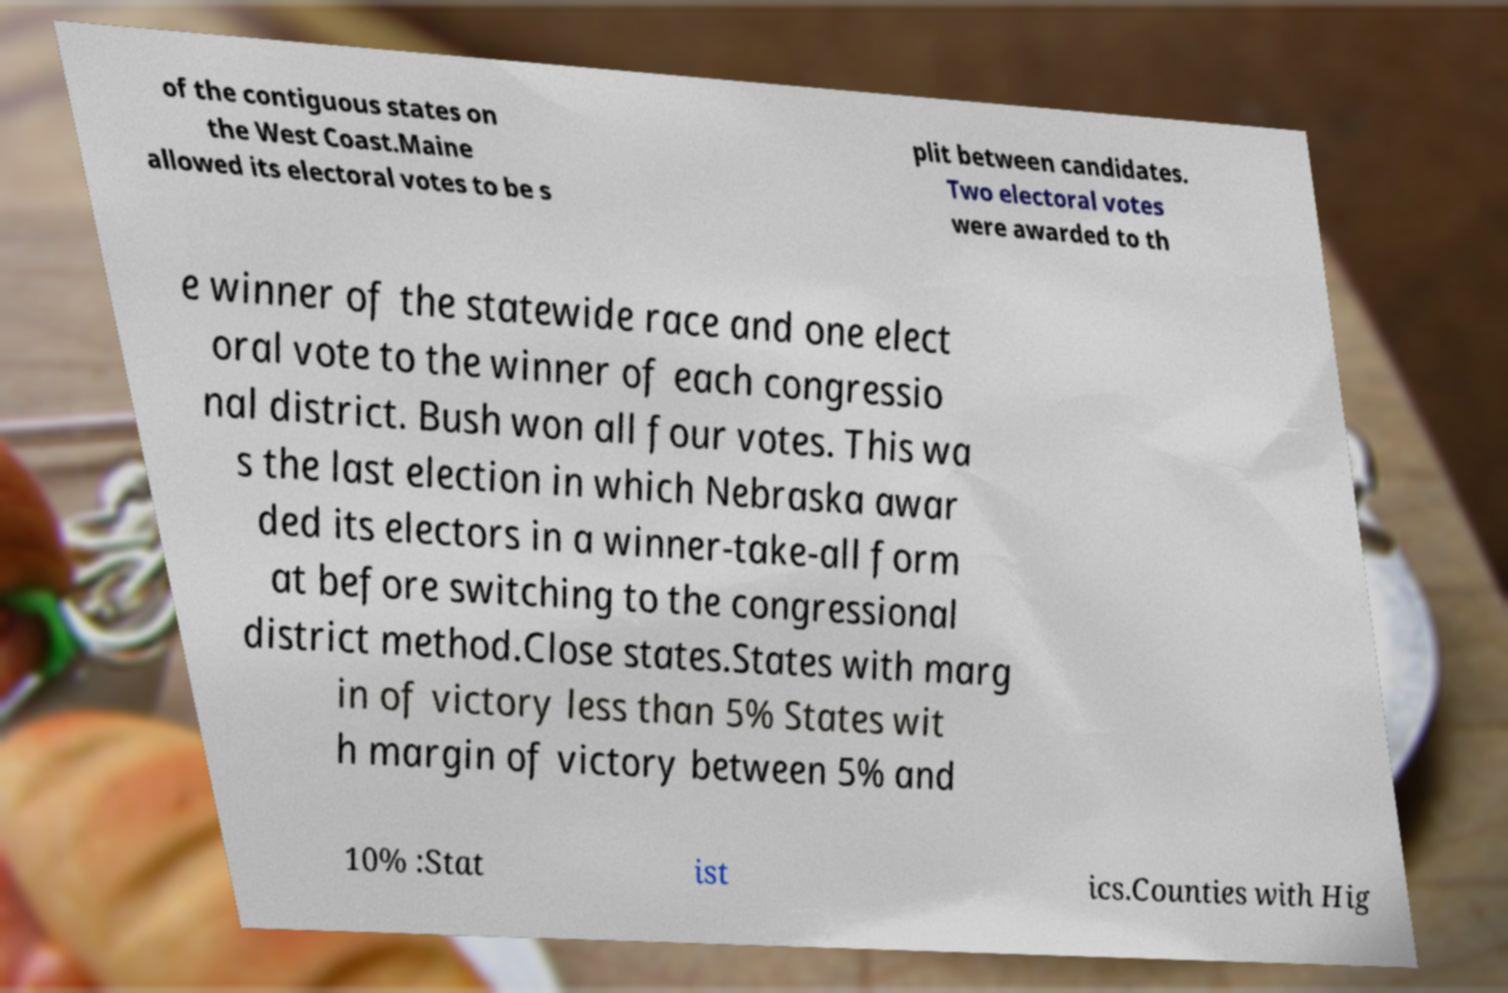What messages or text are displayed in this image? I need them in a readable, typed format. of the contiguous states on the West Coast.Maine allowed its electoral votes to be s plit between candidates. Two electoral votes were awarded to th e winner of the statewide race and one elect oral vote to the winner of each congressio nal district. Bush won all four votes. This wa s the last election in which Nebraska awar ded its electors in a winner-take-all form at before switching to the congressional district method.Close states.States with marg in of victory less than 5% States wit h margin of victory between 5% and 10% :Stat ist ics.Counties with Hig 